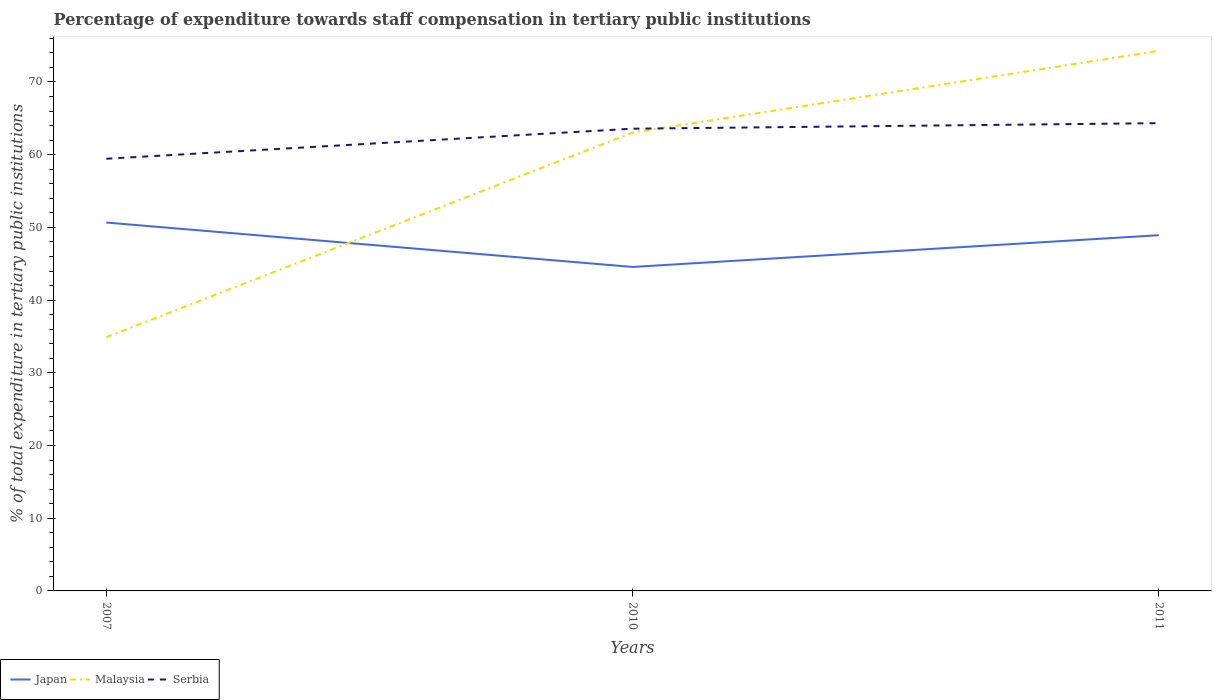Across all years, what is the maximum percentage of expenditure towards staff compensation in Serbia?
Give a very brief answer. 59.44. What is the total percentage of expenditure towards staff compensation in Malaysia in the graph?
Ensure brevity in your answer.  -39.37. What is the difference between the highest and the second highest percentage of expenditure towards staff compensation in Malaysia?
Provide a succinct answer. 39.37. Is the percentage of expenditure towards staff compensation in Malaysia strictly greater than the percentage of expenditure towards staff compensation in Japan over the years?
Provide a short and direct response. No. Are the values on the major ticks of Y-axis written in scientific E-notation?
Your answer should be compact. No. Does the graph contain any zero values?
Offer a terse response. No. Does the graph contain grids?
Keep it short and to the point. No. Where does the legend appear in the graph?
Ensure brevity in your answer.  Bottom left. How are the legend labels stacked?
Provide a succinct answer. Horizontal. What is the title of the graph?
Ensure brevity in your answer.  Percentage of expenditure towards staff compensation in tertiary public institutions. What is the label or title of the Y-axis?
Ensure brevity in your answer.  % of total expenditure in tertiary public institutions. What is the % of total expenditure in tertiary public institutions of Japan in 2007?
Keep it short and to the point. 50.67. What is the % of total expenditure in tertiary public institutions of Malaysia in 2007?
Give a very brief answer. 34.9. What is the % of total expenditure in tertiary public institutions of Serbia in 2007?
Give a very brief answer. 59.44. What is the % of total expenditure in tertiary public institutions in Japan in 2010?
Provide a succinct answer. 44.56. What is the % of total expenditure in tertiary public institutions in Malaysia in 2010?
Your response must be concise. 63.04. What is the % of total expenditure in tertiary public institutions of Serbia in 2010?
Your answer should be compact. 63.57. What is the % of total expenditure in tertiary public institutions of Japan in 2011?
Provide a short and direct response. 48.92. What is the % of total expenditure in tertiary public institutions of Malaysia in 2011?
Give a very brief answer. 74.27. What is the % of total expenditure in tertiary public institutions in Serbia in 2011?
Keep it short and to the point. 64.33. Across all years, what is the maximum % of total expenditure in tertiary public institutions of Japan?
Your answer should be very brief. 50.67. Across all years, what is the maximum % of total expenditure in tertiary public institutions in Malaysia?
Ensure brevity in your answer.  74.27. Across all years, what is the maximum % of total expenditure in tertiary public institutions in Serbia?
Ensure brevity in your answer.  64.33. Across all years, what is the minimum % of total expenditure in tertiary public institutions of Japan?
Provide a short and direct response. 44.56. Across all years, what is the minimum % of total expenditure in tertiary public institutions in Malaysia?
Offer a terse response. 34.9. Across all years, what is the minimum % of total expenditure in tertiary public institutions of Serbia?
Offer a terse response. 59.44. What is the total % of total expenditure in tertiary public institutions in Japan in the graph?
Your response must be concise. 144.15. What is the total % of total expenditure in tertiary public institutions in Malaysia in the graph?
Make the answer very short. 172.22. What is the total % of total expenditure in tertiary public institutions in Serbia in the graph?
Make the answer very short. 187.35. What is the difference between the % of total expenditure in tertiary public institutions in Japan in 2007 and that in 2010?
Offer a very short reply. 6.11. What is the difference between the % of total expenditure in tertiary public institutions in Malaysia in 2007 and that in 2010?
Ensure brevity in your answer.  -28.14. What is the difference between the % of total expenditure in tertiary public institutions of Serbia in 2007 and that in 2010?
Offer a very short reply. -4.13. What is the difference between the % of total expenditure in tertiary public institutions of Japan in 2007 and that in 2011?
Offer a terse response. 1.74. What is the difference between the % of total expenditure in tertiary public institutions of Malaysia in 2007 and that in 2011?
Provide a succinct answer. -39.37. What is the difference between the % of total expenditure in tertiary public institutions in Serbia in 2007 and that in 2011?
Your answer should be very brief. -4.89. What is the difference between the % of total expenditure in tertiary public institutions in Japan in 2010 and that in 2011?
Your answer should be compact. -4.37. What is the difference between the % of total expenditure in tertiary public institutions of Malaysia in 2010 and that in 2011?
Offer a terse response. -11.23. What is the difference between the % of total expenditure in tertiary public institutions in Serbia in 2010 and that in 2011?
Your response must be concise. -0.76. What is the difference between the % of total expenditure in tertiary public institutions of Japan in 2007 and the % of total expenditure in tertiary public institutions of Malaysia in 2010?
Make the answer very short. -12.38. What is the difference between the % of total expenditure in tertiary public institutions in Japan in 2007 and the % of total expenditure in tertiary public institutions in Serbia in 2010?
Your response must be concise. -12.9. What is the difference between the % of total expenditure in tertiary public institutions of Malaysia in 2007 and the % of total expenditure in tertiary public institutions of Serbia in 2010?
Offer a terse response. -28.67. What is the difference between the % of total expenditure in tertiary public institutions in Japan in 2007 and the % of total expenditure in tertiary public institutions in Malaysia in 2011?
Make the answer very short. -23.61. What is the difference between the % of total expenditure in tertiary public institutions in Japan in 2007 and the % of total expenditure in tertiary public institutions in Serbia in 2011?
Your answer should be very brief. -13.66. What is the difference between the % of total expenditure in tertiary public institutions in Malaysia in 2007 and the % of total expenditure in tertiary public institutions in Serbia in 2011?
Offer a terse response. -29.43. What is the difference between the % of total expenditure in tertiary public institutions in Japan in 2010 and the % of total expenditure in tertiary public institutions in Malaysia in 2011?
Ensure brevity in your answer.  -29.72. What is the difference between the % of total expenditure in tertiary public institutions in Japan in 2010 and the % of total expenditure in tertiary public institutions in Serbia in 2011?
Provide a short and direct response. -19.78. What is the difference between the % of total expenditure in tertiary public institutions in Malaysia in 2010 and the % of total expenditure in tertiary public institutions in Serbia in 2011?
Provide a short and direct response. -1.29. What is the average % of total expenditure in tertiary public institutions in Japan per year?
Ensure brevity in your answer.  48.05. What is the average % of total expenditure in tertiary public institutions in Malaysia per year?
Your answer should be compact. 57.41. What is the average % of total expenditure in tertiary public institutions in Serbia per year?
Provide a succinct answer. 62.45. In the year 2007, what is the difference between the % of total expenditure in tertiary public institutions in Japan and % of total expenditure in tertiary public institutions in Malaysia?
Offer a very short reply. 15.77. In the year 2007, what is the difference between the % of total expenditure in tertiary public institutions in Japan and % of total expenditure in tertiary public institutions in Serbia?
Give a very brief answer. -8.77. In the year 2007, what is the difference between the % of total expenditure in tertiary public institutions in Malaysia and % of total expenditure in tertiary public institutions in Serbia?
Keep it short and to the point. -24.54. In the year 2010, what is the difference between the % of total expenditure in tertiary public institutions in Japan and % of total expenditure in tertiary public institutions in Malaysia?
Give a very brief answer. -18.49. In the year 2010, what is the difference between the % of total expenditure in tertiary public institutions of Japan and % of total expenditure in tertiary public institutions of Serbia?
Your answer should be very brief. -19.02. In the year 2010, what is the difference between the % of total expenditure in tertiary public institutions in Malaysia and % of total expenditure in tertiary public institutions in Serbia?
Your answer should be very brief. -0.53. In the year 2011, what is the difference between the % of total expenditure in tertiary public institutions of Japan and % of total expenditure in tertiary public institutions of Malaysia?
Your answer should be compact. -25.35. In the year 2011, what is the difference between the % of total expenditure in tertiary public institutions in Japan and % of total expenditure in tertiary public institutions in Serbia?
Ensure brevity in your answer.  -15.41. In the year 2011, what is the difference between the % of total expenditure in tertiary public institutions of Malaysia and % of total expenditure in tertiary public institutions of Serbia?
Provide a succinct answer. 9.94. What is the ratio of the % of total expenditure in tertiary public institutions in Japan in 2007 to that in 2010?
Your response must be concise. 1.14. What is the ratio of the % of total expenditure in tertiary public institutions in Malaysia in 2007 to that in 2010?
Your answer should be compact. 0.55. What is the ratio of the % of total expenditure in tertiary public institutions of Serbia in 2007 to that in 2010?
Make the answer very short. 0.94. What is the ratio of the % of total expenditure in tertiary public institutions in Japan in 2007 to that in 2011?
Your response must be concise. 1.04. What is the ratio of the % of total expenditure in tertiary public institutions in Malaysia in 2007 to that in 2011?
Offer a terse response. 0.47. What is the ratio of the % of total expenditure in tertiary public institutions in Serbia in 2007 to that in 2011?
Ensure brevity in your answer.  0.92. What is the ratio of the % of total expenditure in tertiary public institutions in Japan in 2010 to that in 2011?
Keep it short and to the point. 0.91. What is the ratio of the % of total expenditure in tertiary public institutions in Malaysia in 2010 to that in 2011?
Give a very brief answer. 0.85. What is the difference between the highest and the second highest % of total expenditure in tertiary public institutions of Japan?
Ensure brevity in your answer.  1.74. What is the difference between the highest and the second highest % of total expenditure in tertiary public institutions in Malaysia?
Make the answer very short. 11.23. What is the difference between the highest and the second highest % of total expenditure in tertiary public institutions of Serbia?
Keep it short and to the point. 0.76. What is the difference between the highest and the lowest % of total expenditure in tertiary public institutions in Japan?
Make the answer very short. 6.11. What is the difference between the highest and the lowest % of total expenditure in tertiary public institutions in Malaysia?
Keep it short and to the point. 39.37. What is the difference between the highest and the lowest % of total expenditure in tertiary public institutions of Serbia?
Offer a very short reply. 4.89. 